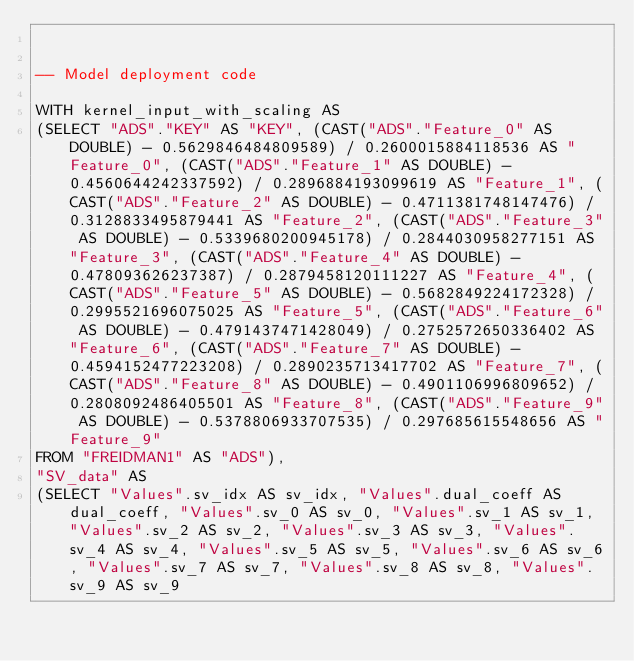Convert code to text. <code><loc_0><loc_0><loc_500><loc_500><_SQL_>

-- Model deployment code

WITH kernel_input_with_scaling AS 
(SELECT "ADS"."KEY" AS "KEY", (CAST("ADS"."Feature_0" AS DOUBLE) - 0.5629846484809589) / 0.2600015884118536 AS "Feature_0", (CAST("ADS"."Feature_1" AS DOUBLE) - 0.4560644242337592) / 0.2896884193099619 AS "Feature_1", (CAST("ADS"."Feature_2" AS DOUBLE) - 0.4711381748147476) / 0.3128833495879441 AS "Feature_2", (CAST("ADS"."Feature_3" AS DOUBLE) - 0.5339680200945178) / 0.2844030958277151 AS "Feature_3", (CAST("ADS"."Feature_4" AS DOUBLE) - 0.478093626237387) / 0.2879458120111227 AS "Feature_4", (CAST("ADS"."Feature_5" AS DOUBLE) - 0.5682849224172328) / 0.2995521696075025 AS "Feature_5", (CAST("ADS"."Feature_6" AS DOUBLE) - 0.4791437471428049) / 0.2752572650336402 AS "Feature_6", (CAST("ADS"."Feature_7" AS DOUBLE) - 0.4594152477223208) / 0.2890235713417702 AS "Feature_7", (CAST("ADS"."Feature_8" AS DOUBLE) - 0.4901106996809652) / 0.2808092486405501 AS "Feature_8", (CAST("ADS"."Feature_9" AS DOUBLE) - 0.5378806933707535) / 0.297685615548656 AS "Feature_9" 
FROM "FREIDMAN1" AS "ADS"), 
"SV_data" AS 
(SELECT "Values".sv_idx AS sv_idx, "Values".dual_coeff AS dual_coeff, "Values".sv_0 AS sv_0, "Values".sv_1 AS sv_1, "Values".sv_2 AS sv_2, "Values".sv_3 AS sv_3, "Values".sv_4 AS sv_4, "Values".sv_5 AS sv_5, "Values".sv_6 AS sv_6, "Values".sv_7 AS sv_7, "Values".sv_8 AS sv_8, "Values".sv_9 AS sv_9 </code> 